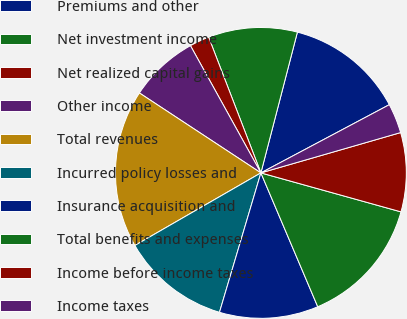Convert chart to OTSL. <chart><loc_0><loc_0><loc_500><loc_500><pie_chart><fcel>Premiums and other<fcel>Net investment income<fcel>Net realized capital gains<fcel>Other income<fcel>Total revenues<fcel>Incurred policy losses and<fcel>Insurance acquisition and<fcel>Total benefits and expenses<fcel>Income before income taxes<fcel>Income taxes<nl><fcel>13.19%<fcel>9.89%<fcel>2.2%<fcel>7.69%<fcel>17.58%<fcel>12.09%<fcel>10.99%<fcel>14.29%<fcel>8.79%<fcel>3.3%<nl></chart> 